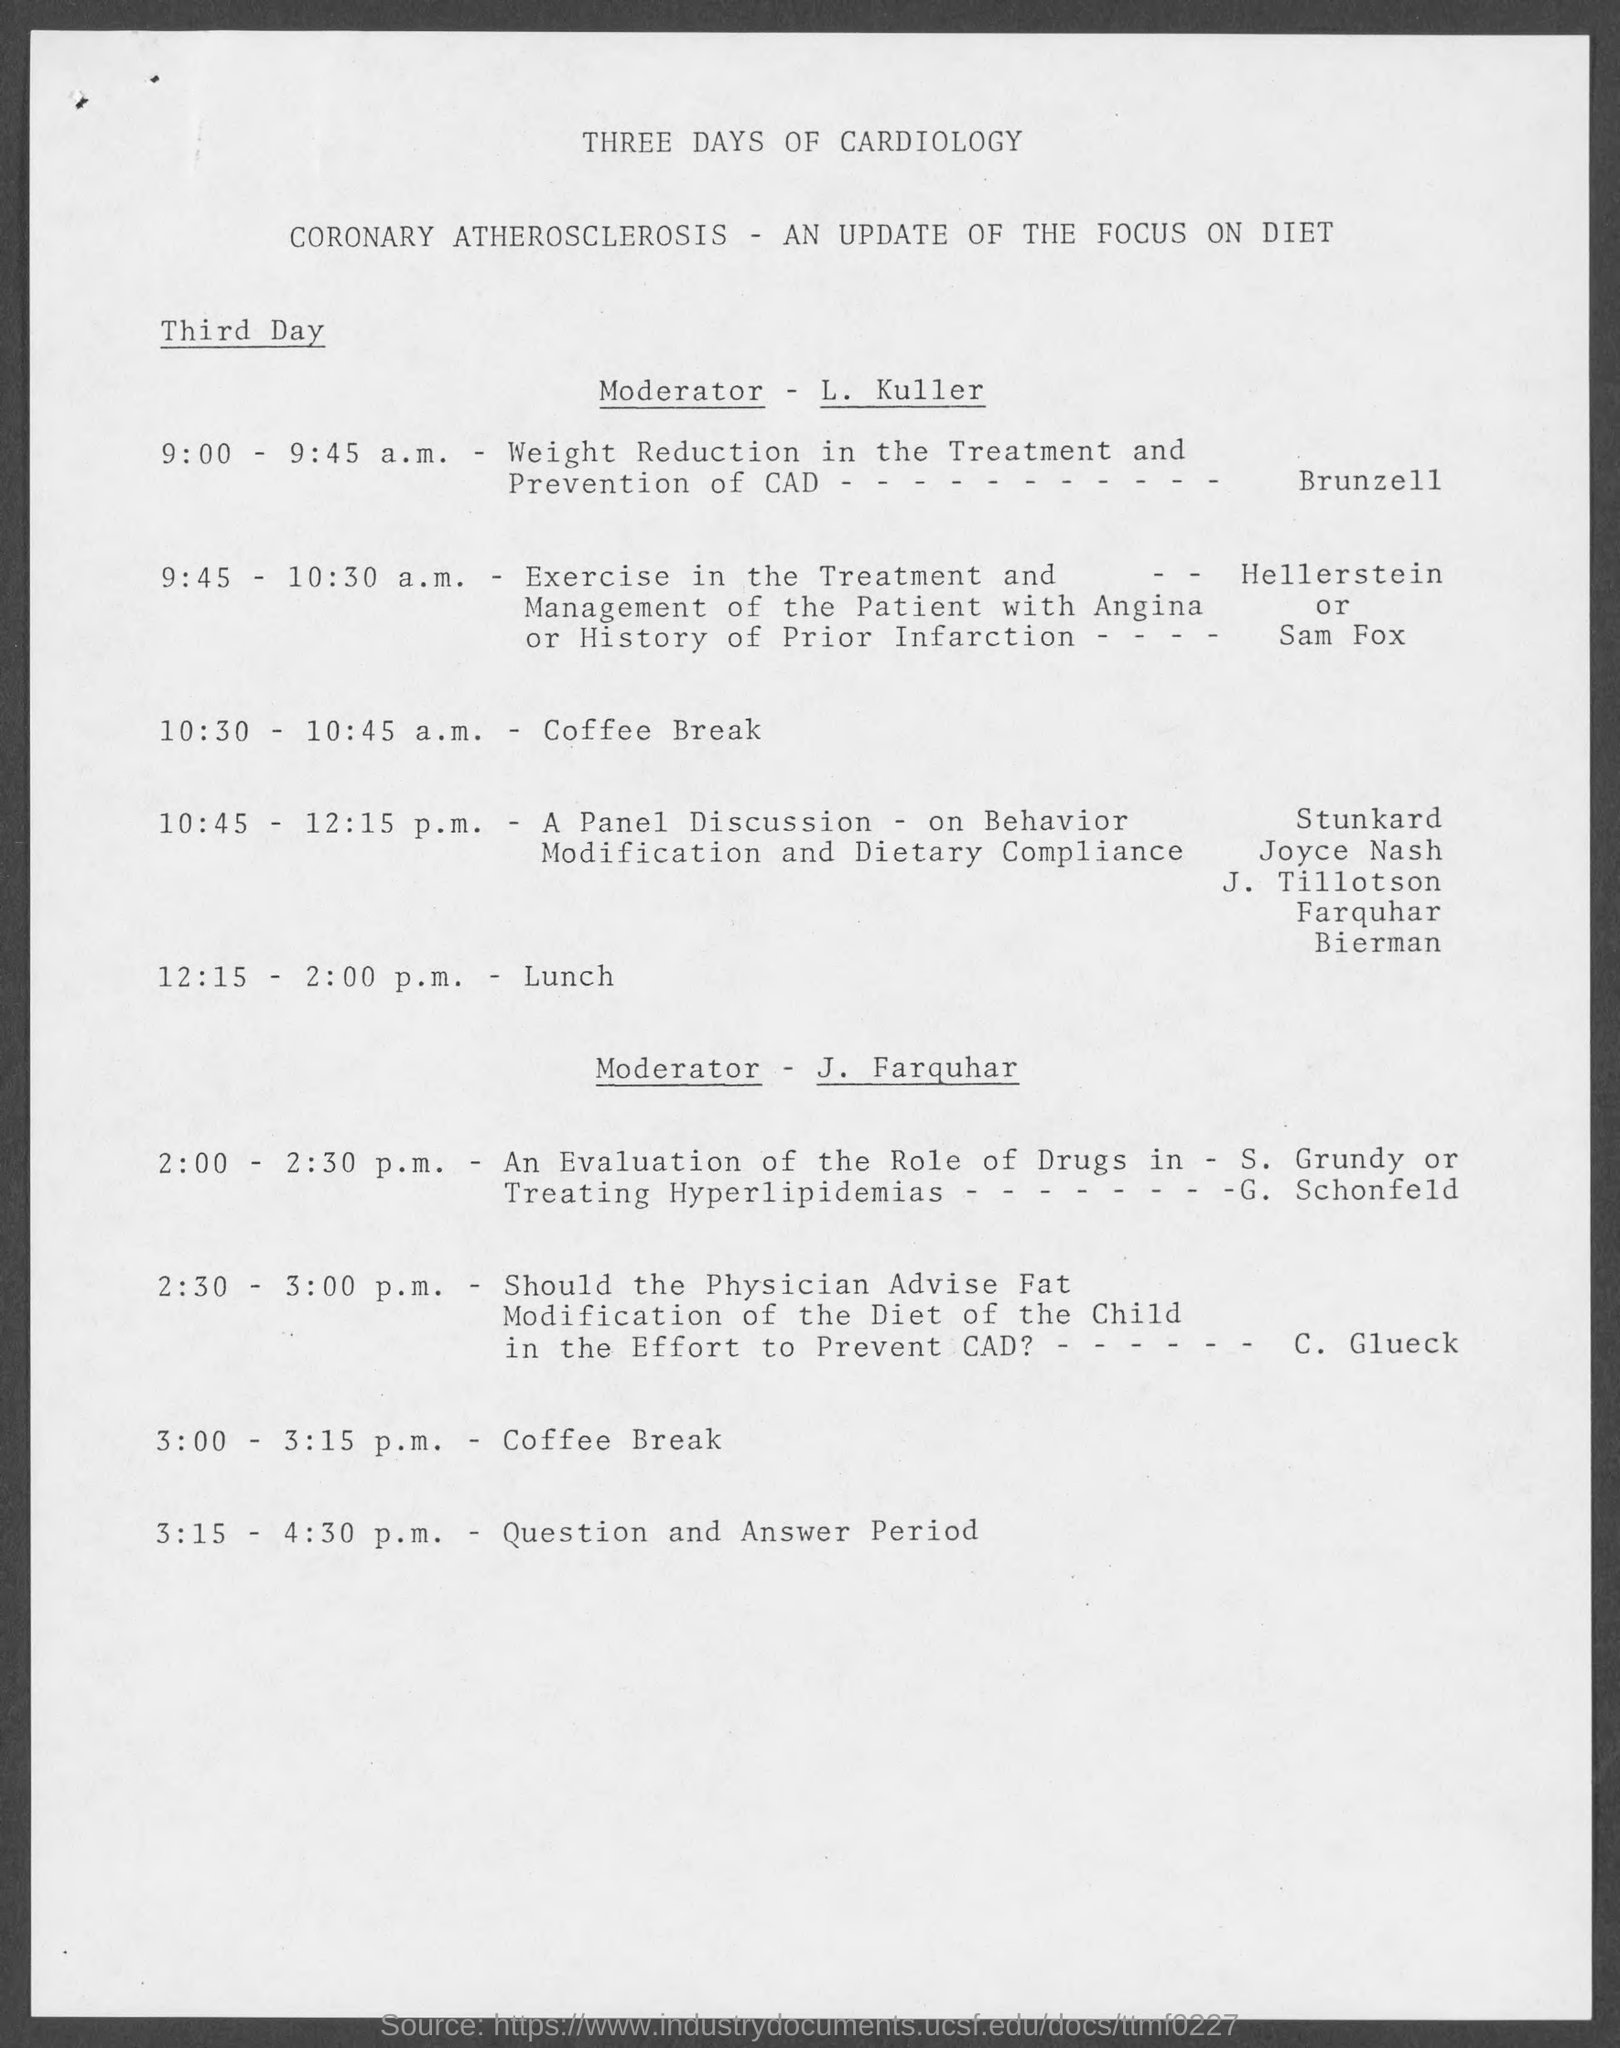When is the Coffee Break?
Offer a very short reply. 10:30 - 10:45 a.m. When is the Lunch?
Give a very brief answer. 12:15 - 2:00. 